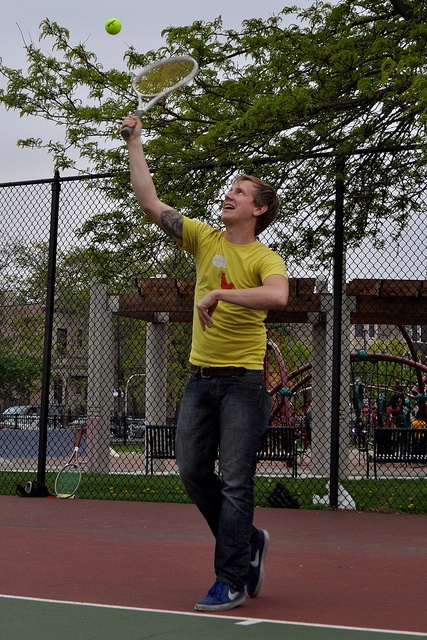Describe the objects in this image and their specific colors. I can see people in darkgray, black, olive, and gray tones, tennis racket in darkgray, olive, and gray tones, people in darkgray, black, maroon, and purple tones, people in darkgray, black, maroon, olive, and orange tones, and sports ball in darkgray, darkgreen, olive, and lime tones in this image. 